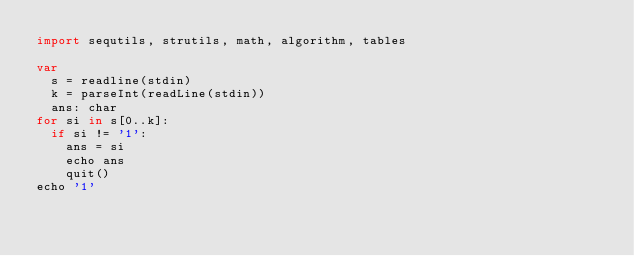<code> <loc_0><loc_0><loc_500><loc_500><_Nim_>import sequtils, strutils, math, algorithm, tables

var
  s = readline(stdin)
  k = parseInt(readLine(stdin))
  ans: char
for si in s[0..k]:
  if si != '1':
    ans = si
    echo ans
    quit()
echo '1'</code> 